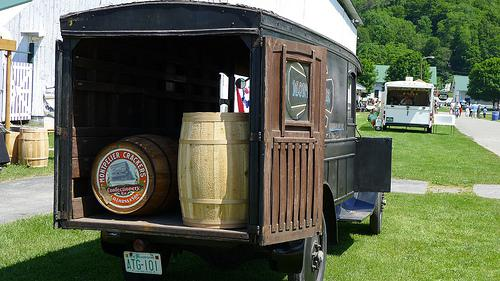Question: what does it say are in the barrels?
Choices:
A. Crackers.
B. Peanuts.
C. Berries.
D. Apples.
Answer with the letter. Answer: A Question: how many barrels are there in the truck?
Choices:
A. 2.
B. 1.
C. 3.
D. 4.
Answer with the letter. Answer: A Question: why is the truck parked?
Choices:
A. To sell crackers.
B. To pick up produce.
C. To sell corn.
D. To offer fresh peaches.
Answer with the letter. Answer: A Question: who is pictured?
Choices:
A. A group of women.
B. People in the background.
C. Some men.
D. Children playing.
Answer with the letter. Answer: B Question: where are the barrels of crackers?
Choices:
A. On the floor.
B. Being unloaded.
C. In the store.
D. In the truck.
Answer with the letter. Answer: D 